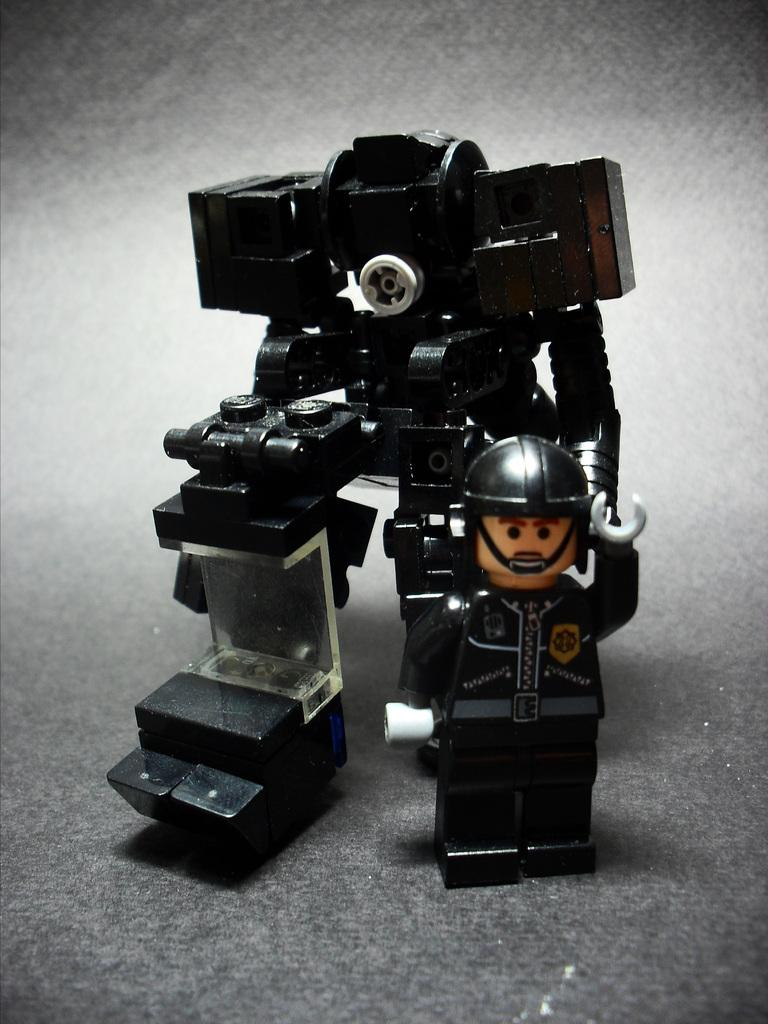What can be seen in the image? There is an object in the image. Can you describe the object's location? The object is on a surface. What language is spoken by the rabbit in the image? There is no rabbit present in the image, and therefore no language spoken by a rabbit can be observed. 